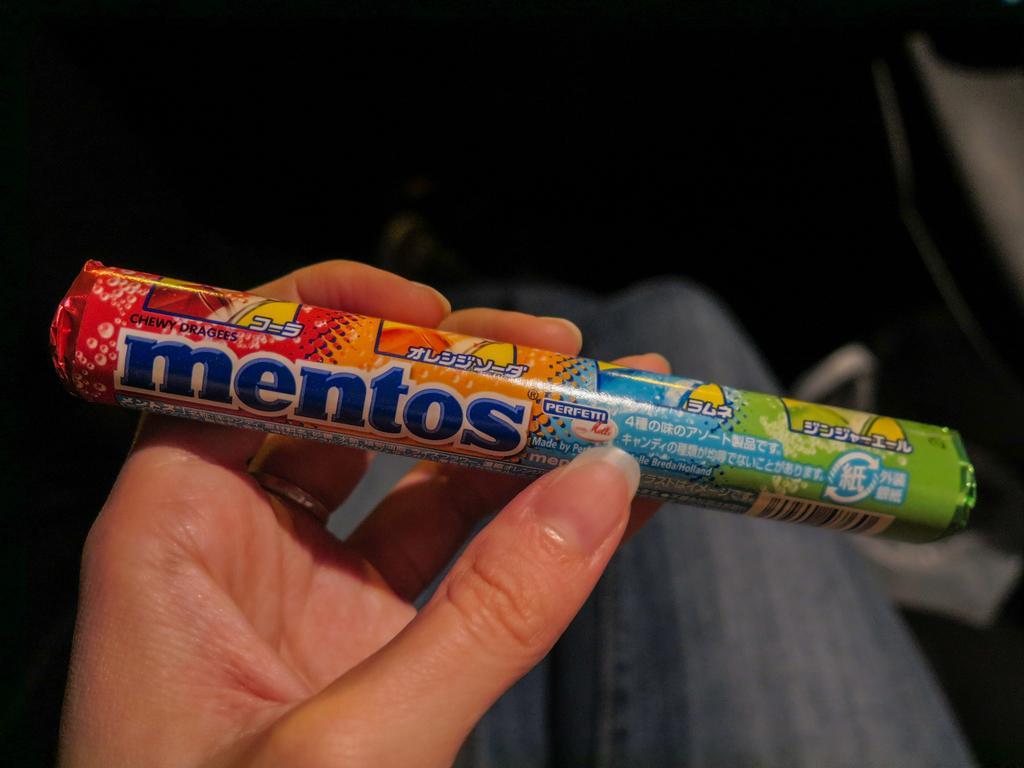Please provide a concise description of this image. As we can see in the image there is a person holding mentos. 